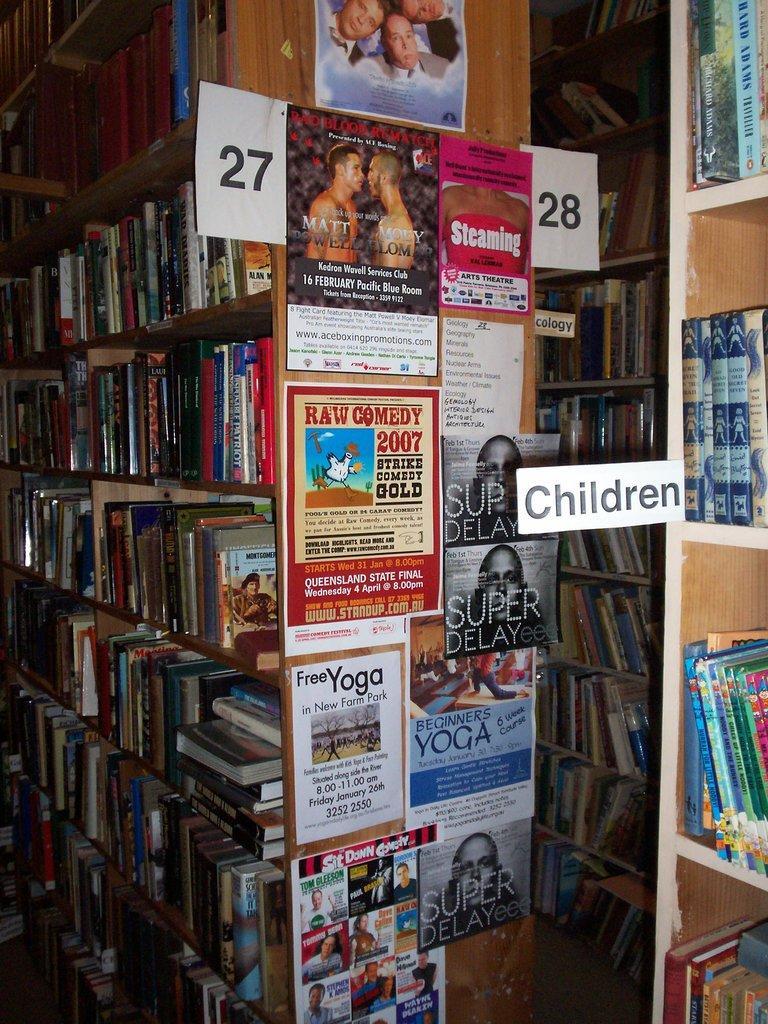Please provide a concise description of this image. In this image I can see few racks which are brown in color and number of posts attached to the racks. I can see few white colored boards attached to the racks and number of books in the racks. 